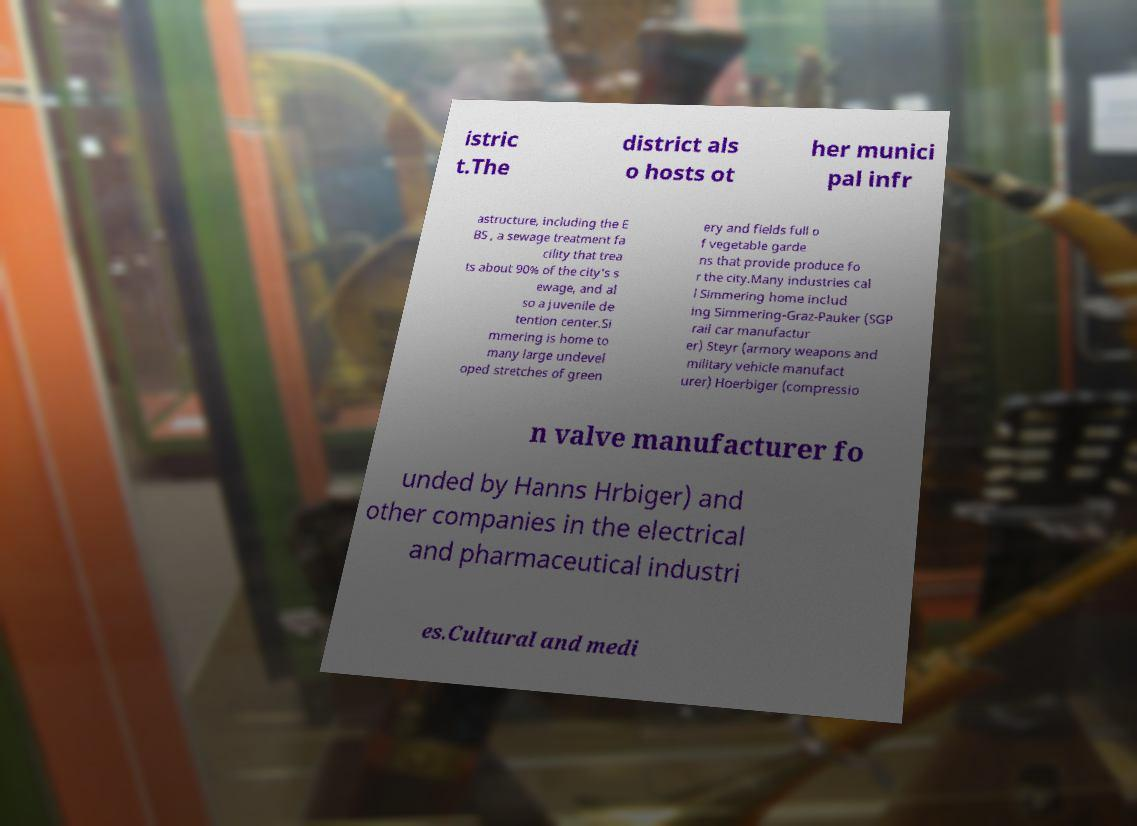I need the written content from this picture converted into text. Can you do that? istric t.The district als o hosts ot her munici pal infr astructure, including the E BS , a sewage treatment fa cility that trea ts about 90% of the city's s ewage, and al so a juvenile de tention center.Si mmering is home to many large undevel oped stretches of green ery and fields full o f vegetable garde ns that provide produce fo r the city.Many industries cal l Simmering home includ ing Simmering-Graz-Pauker (SGP rail car manufactur er) Steyr (armory weapons and military vehicle manufact urer) Hoerbiger (compressio n valve manufacturer fo unded by Hanns Hrbiger) and other companies in the electrical and pharmaceutical industri es.Cultural and medi 